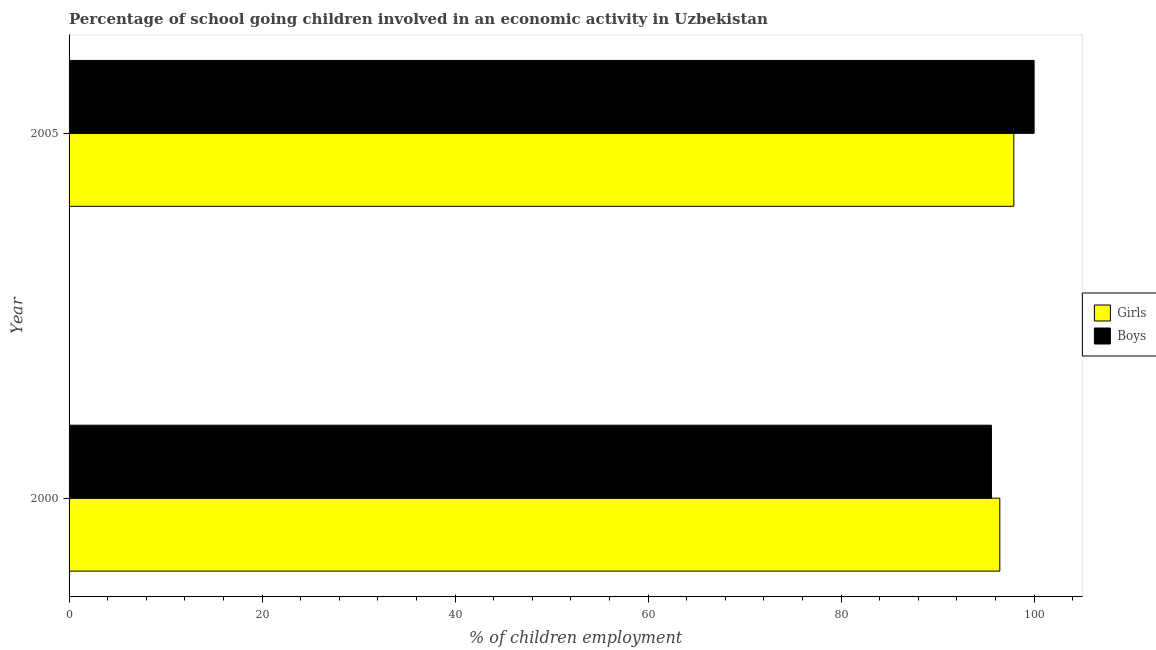What is the label of the 1st group of bars from the top?
Offer a terse response. 2005. In how many cases, is the number of bars for a given year not equal to the number of legend labels?
Your answer should be very brief. 0. What is the percentage of school going boys in 2000?
Provide a short and direct response. 95.58. Across all years, what is the maximum percentage of school going girls?
Provide a short and direct response. 97.9. Across all years, what is the minimum percentage of school going girls?
Give a very brief answer. 96.45. In which year was the percentage of school going boys maximum?
Provide a short and direct response. 2005. In which year was the percentage of school going boys minimum?
Offer a terse response. 2000. What is the total percentage of school going girls in the graph?
Your response must be concise. 194.35. What is the difference between the percentage of school going boys in 2000 and that in 2005?
Offer a terse response. -4.42. What is the difference between the percentage of school going boys in 2000 and the percentage of school going girls in 2005?
Provide a succinct answer. -2.32. What is the average percentage of school going boys per year?
Offer a very short reply. 97.79. In the year 2000, what is the difference between the percentage of school going boys and percentage of school going girls?
Offer a terse response. -0.87. In how many years, is the percentage of school going girls greater than 64 %?
Your answer should be very brief. 2. Is the difference between the percentage of school going boys in 2000 and 2005 greater than the difference between the percentage of school going girls in 2000 and 2005?
Offer a terse response. No. What does the 2nd bar from the top in 2000 represents?
Offer a terse response. Girls. What does the 1st bar from the bottom in 2000 represents?
Give a very brief answer. Girls. How many bars are there?
Offer a very short reply. 4. Are all the bars in the graph horizontal?
Keep it short and to the point. Yes. How many years are there in the graph?
Your answer should be very brief. 2. Are the values on the major ticks of X-axis written in scientific E-notation?
Offer a terse response. No. Does the graph contain any zero values?
Provide a succinct answer. No. Does the graph contain grids?
Give a very brief answer. No. Where does the legend appear in the graph?
Your answer should be very brief. Center right. How many legend labels are there?
Your response must be concise. 2. What is the title of the graph?
Your answer should be compact. Percentage of school going children involved in an economic activity in Uzbekistan. Does "Diesel" appear as one of the legend labels in the graph?
Your response must be concise. No. What is the label or title of the X-axis?
Your answer should be very brief. % of children employment. What is the % of children employment of Girls in 2000?
Your answer should be very brief. 96.45. What is the % of children employment of Boys in 2000?
Your response must be concise. 95.58. What is the % of children employment of Girls in 2005?
Your response must be concise. 97.9. What is the % of children employment in Boys in 2005?
Give a very brief answer. 100. Across all years, what is the maximum % of children employment of Girls?
Provide a succinct answer. 97.9. Across all years, what is the minimum % of children employment of Girls?
Offer a very short reply. 96.45. Across all years, what is the minimum % of children employment of Boys?
Offer a very short reply. 95.58. What is the total % of children employment in Girls in the graph?
Offer a terse response. 194.35. What is the total % of children employment of Boys in the graph?
Offer a very short reply. 195.58. What is the difference between the % of children employment in Girls in 2000 and that in 2005?
Provide a succinct answer. -1.45. What is the difference between the % of children employment of Boys in 2000 and that in 2005?
Give a very brief answer. -4.42. What is the difference between the % of children employment in Girls in 2000 and the % of children employment in Boys in 2005?
Ensure brevity in your answer.  -3.55. What is the average % of children employment of Girls per year?
Offer a terse response. 97.17. What is the average % of children employment in Boys per year?
Keep it short and to the point. 97.79. In the year 2000, what is the difference between the % of children employment in Girls and % of children employment in Boys?
Offer a terse response. 0.87. In the year 2005, what is the difference between the % of children employment of Girls and % of children employment of Boys?
Your answer should be compact. -2.1. What is the ratio of the % of children employment of Girls in 2000 to that in 2005?
Make the answer very short. 0.99. What is the ratio of the % of children employment of Boys in 2000 to that in 2005?
Provide a succinct answer. 0.96. What is the difference between the highest and the second highest % of children employment of Girls?
Give a very brief answer. 1.45. What is the difference between the highest and the second highest % of children employment of Boys?
Provide a succinct answer. 4.42. What is the difference between the highest and the lowest % of children employment in Girls?
Your response must be concise. 1.45. What is the difference between the highest and the lowest % of children employment in Boys?
Your answer should be very brief. 4.42. 